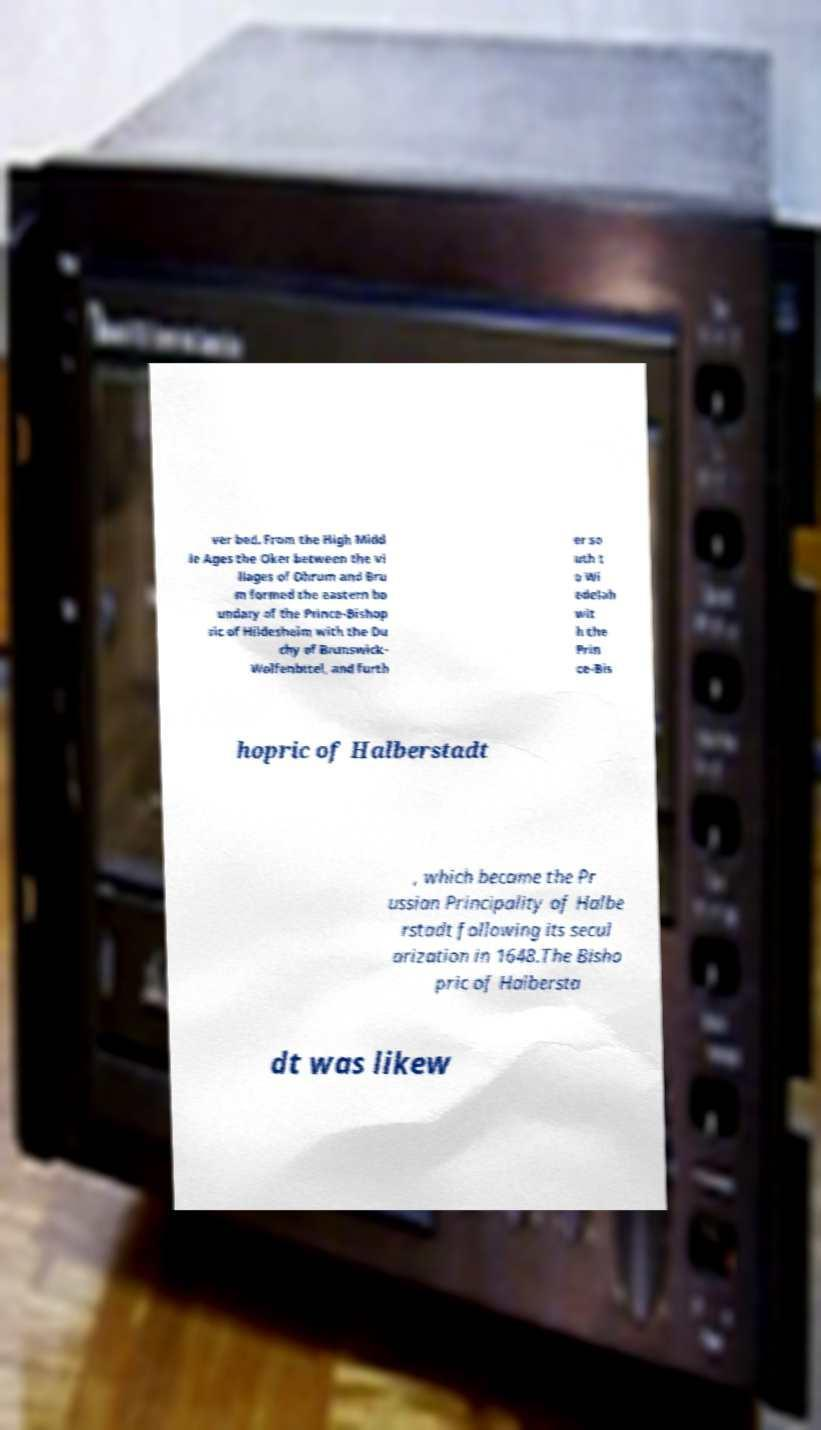I need the written content from this picture converted into text. Can you do that? ver bed. From the High Midd le Ages the Oker between the vi llages of Ohrum and Bru m formed the eastern bo undary of the Prince-Bishop ric of Hildesheim with the Du chy of Brunswick- Wolfenbttel, and furth er so uth t o Wi edelah wit h the Prin ce-Bis hopric of Halberstadt , which became the Pr ussian Principality of Halbe rstadt following its secul arization in 1648.The Bisho pric of Halbersta dt was likew 